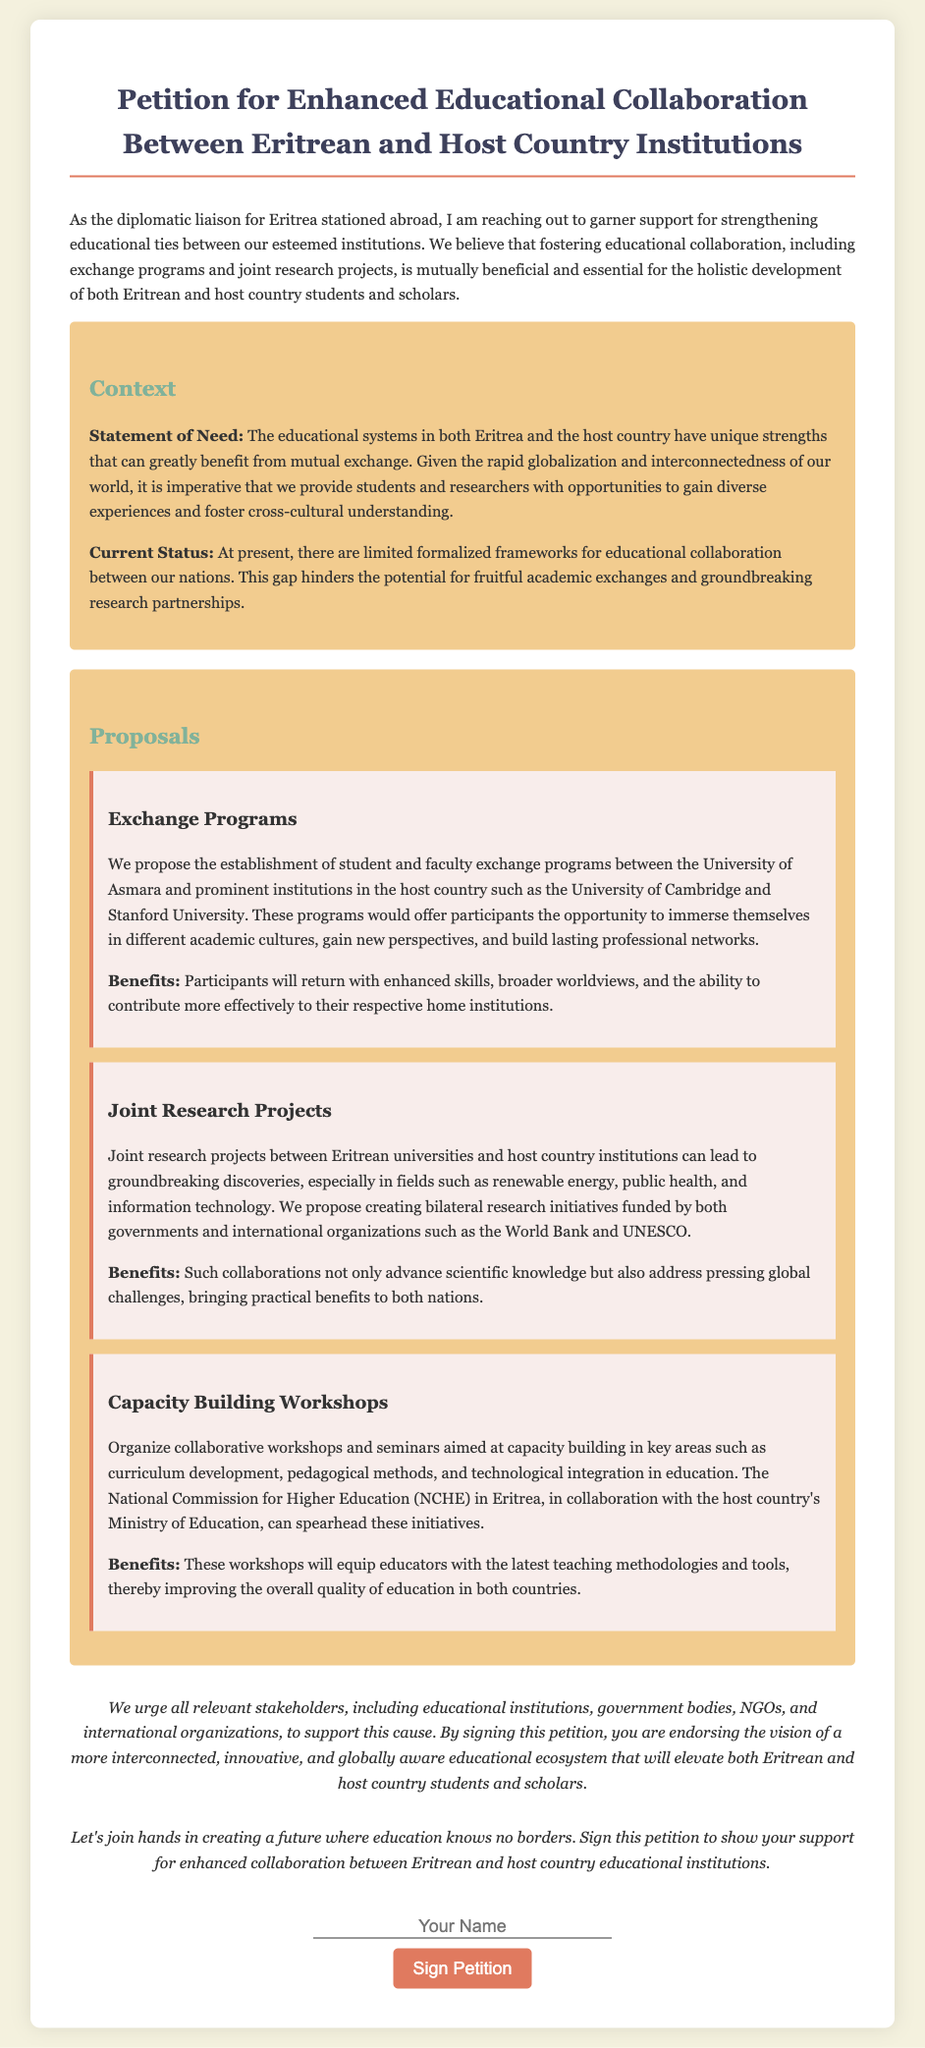What is the title of the petition? The title of the petition is stated at the top of the document.
Answer: Petition for Enhanced Educational Collaboration Between Eritrean and Host Country Institutions What university in Eritrea is mentioned for exchange programs? The document specifies a particular university in Eritrea for the proposed exchange programs.
Answer: University of Asmara What are the proposed areas for joint research projects? The document lists specific fields where joint research is proposed, indicating the focus areas for cooperation.
Answer: renewable energy, public health, and information technology Who should support this educational collaboration initiative? The petition calls on a variety of stakeholders to endorse the initiative, mentioned towards the end.
Answer: relevant stakeholders, including educational institutions, government bodies, NGOs, and international organizations What type of workshops are proposed for capacity building? The document specifies the type of workshops aimed at improving educational methods and tools.
Answer: collaborative workshops and seminars 